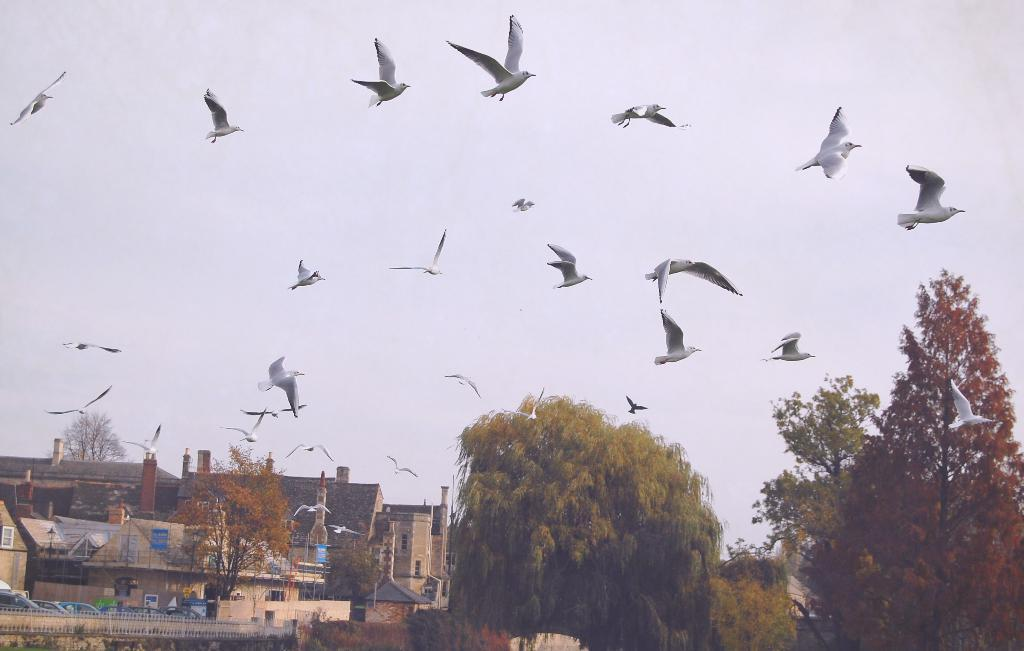What type of structures can be seen in the image? There are buildings in the image. What is present near the buildings? There is fencing in the image. What else can be seen in the image besides buildings and fencing? There are vehicles and trees in the image. What is happening in the sky in the image? Birds are flying in the image. What color is the sky in the image? The sky is white in color. What type of company is represented by the stick in the image? There is no stick present in the image, so it is not possible to determine what type of company it might represent. 